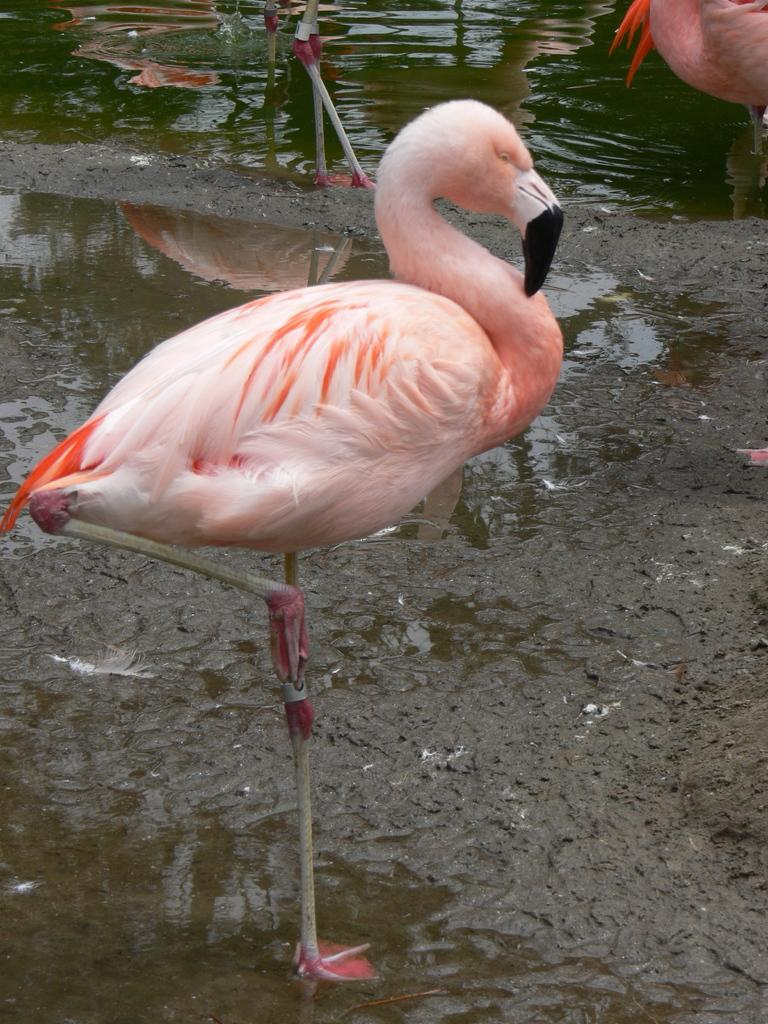What is the primary element visible in the picture? There is water in the picture. What type of birds can be seen in the picture? There are cranes in the picture. What type of bean is being cooked in the water in the picture? There is no bean present in the picture; it features water and cranes. What type of instrument can be heard playing in the background of the picture? There is no instrument or sound present in the picture; it only features water and cranes. 